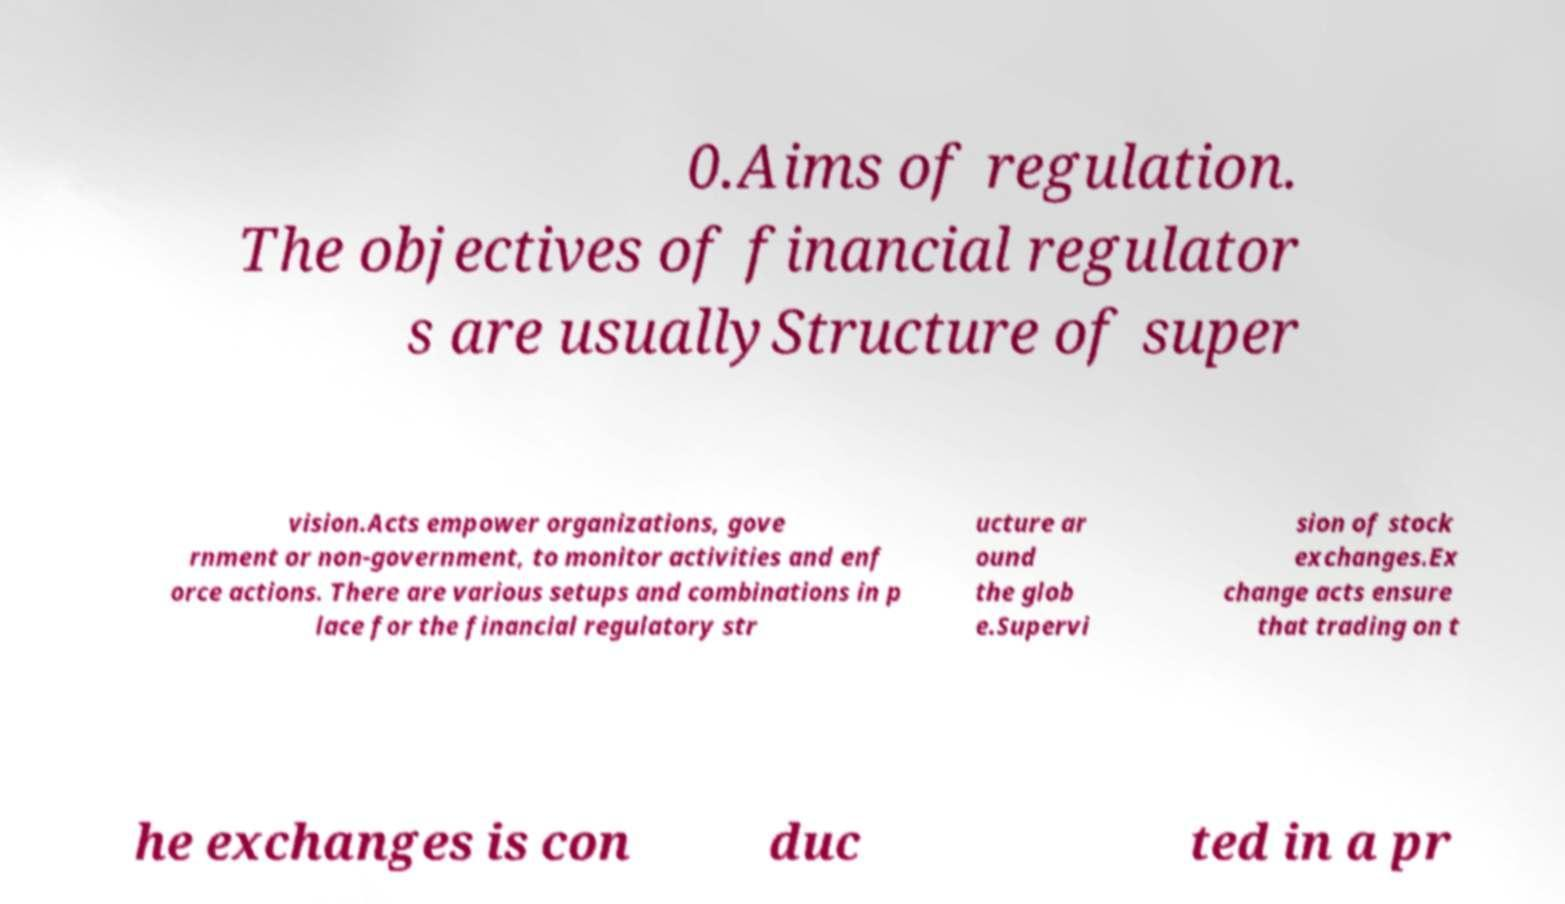What messages or text are displayed in this image? I need them in a readable, typed format. 0.Aims of regulation. The objectives of financial regulator s are usuallyStructure of super vision.Acts empower organizations, gove rnment or non-government, to monitor activities and enf orce actions. There are various setups and combinations in p lace for the financial regulatory str ucture ar ound the glob e.Supervi sion of stock exchanges.Ex change acts ensure that trading on t he exchanges is con duc ted in a pr 